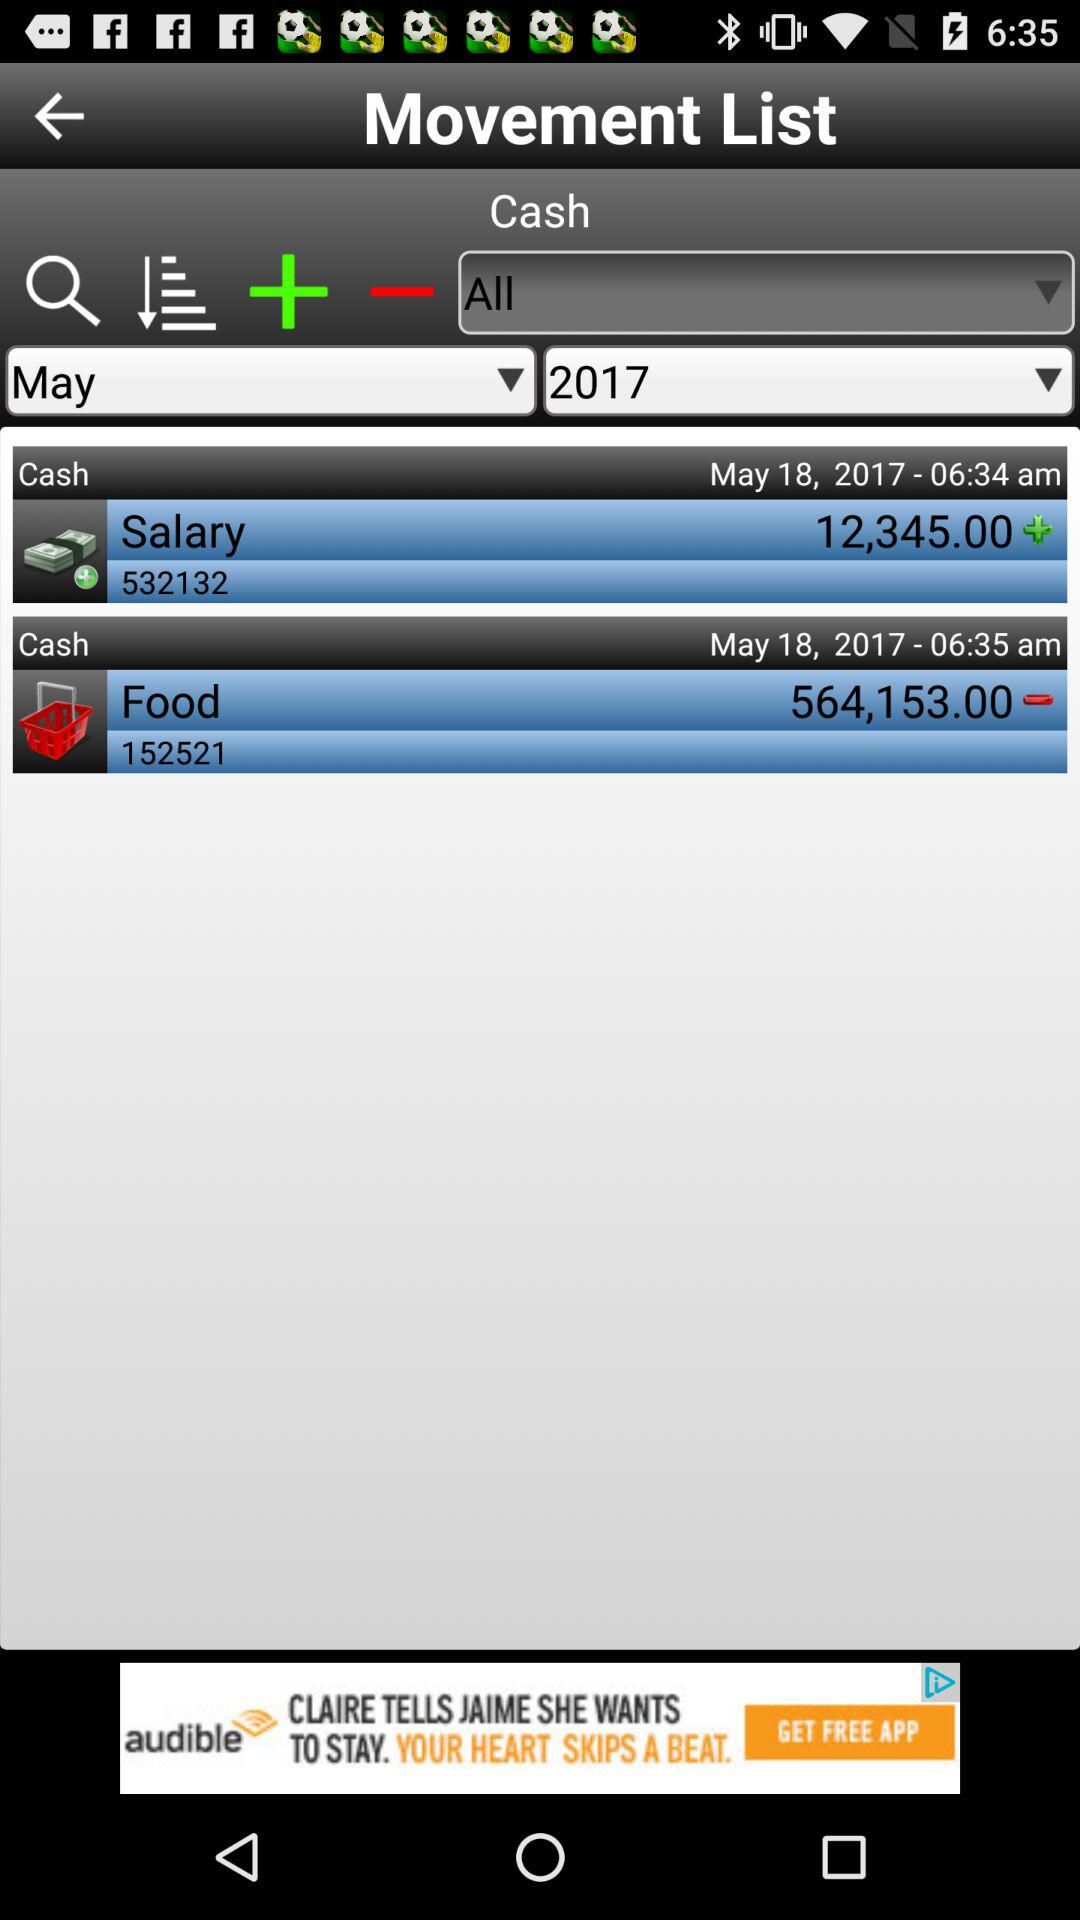What's the amount for food expenses? The amount is 564,153.00. 